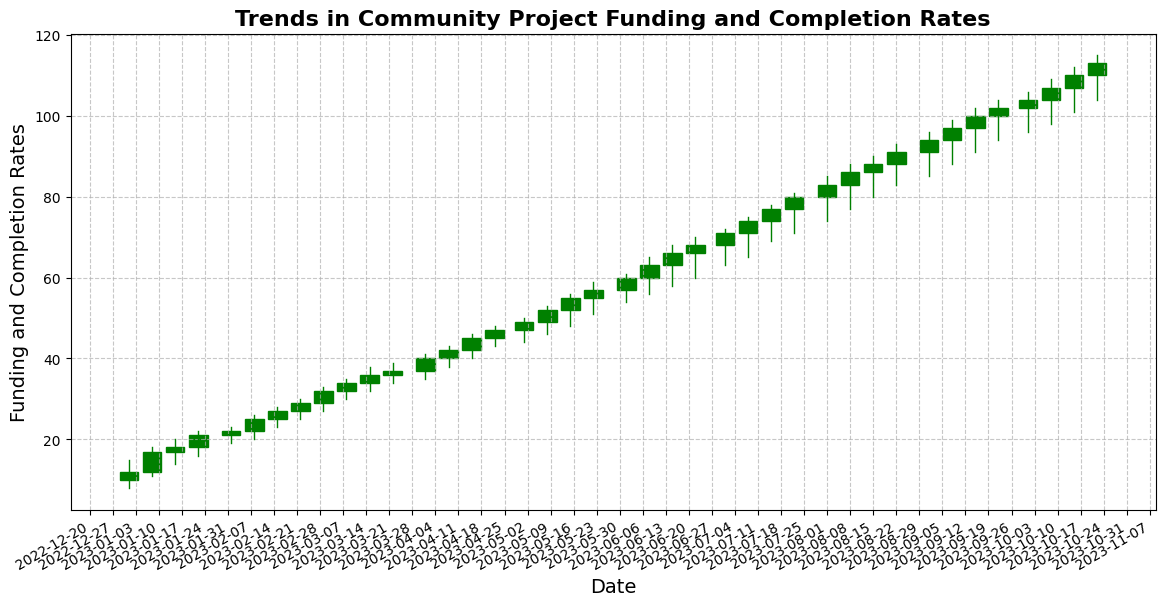What is the overall trend in the funding and completion rates between January 2023 and October 2023? The figure shows a consistent upward trend in the candlestick plot from January 2023 to October 2023, indicating that both the funding and completion rates have been increasing steadily during this period.
Answer: Increasing What is the highest funding/closure rate achieved within the observed timeframe? The highest closing rate is visible at the far right of the chart, which represents the latest date available; this occurs on October 22, 2023, with a closing value of 113.
Answer: 113 Was there any significant drop in funding/closure rates during the observed period? By observing the candlestick patterns, there are no significant drops where the closing rate falls below the opening rate in a substantial manner. The funding/closure rate consistently increases.
Answer: No Which month shows the largest increase in funding/closure rates? By comparing the closing values at the beginning and end of each month, the largest increase occurs from June 1, 2023, with a closing rate of 60, to July 1, 2023, with a closing rate of 71, which is an increase of 11 points.
Answer: June to July How does the trend between July and August compare to the trend between March and April in terms of funding/closure rate growth? From July 1, 2023, to August 1, 2023, the closing rate increases from 71 to 83, which is a growth of 12 points. During March 1, 2023, to April 1, 2023, the closing rate increases from 32 to 40, which is a growth of 8 points. Comparing both, the increase in funding/closure rates is higher between July and August.
Answer: Higher growth between July and August What pattern is visible in the candlestick color distribution through the observed period? The majority of the candlesticks are green, indicating that most weeks saw a rise in funding and completion rates (where the closing value is higher than the opening value). This shows a general trend of increasing rates.
Answer: Mostly green Which weeks have the highest high versus the lowest low during the period? The week with the highest high is October 22, 2023, with a high of 115. The week with the lowest low is January 1, 2023, with a low of 8.
Answer: October 22, 2023, and January 1, 2023 What is the difference between the highest and lowest closing rates in the figure? The highest closing rate is 113 on October 22, 2023, and the lowest closing rate is 12 on January 1, 2023. The difference between them is 113 - 12 = 101.
Answer: 101 Which month displays the highest volatility in funding/closure rates? Volatility can be observed by the average range of the candlesticks (high to low prices) within each month. September shows the highest volatility, with a range from a low of 85 to a high of 102, indicating significant fluctuations within the month.
Answer: September 